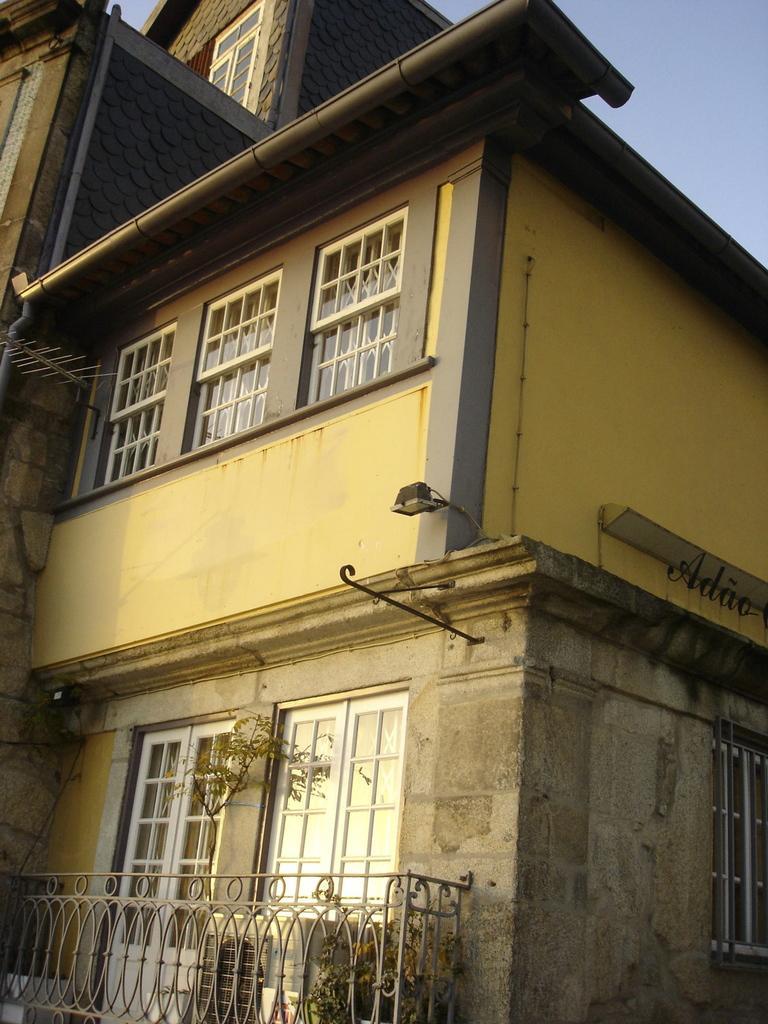Can you describe this image briefly? In this image in the center there is a building and on the building there are windows, doors. In front of the building there is a fence. 